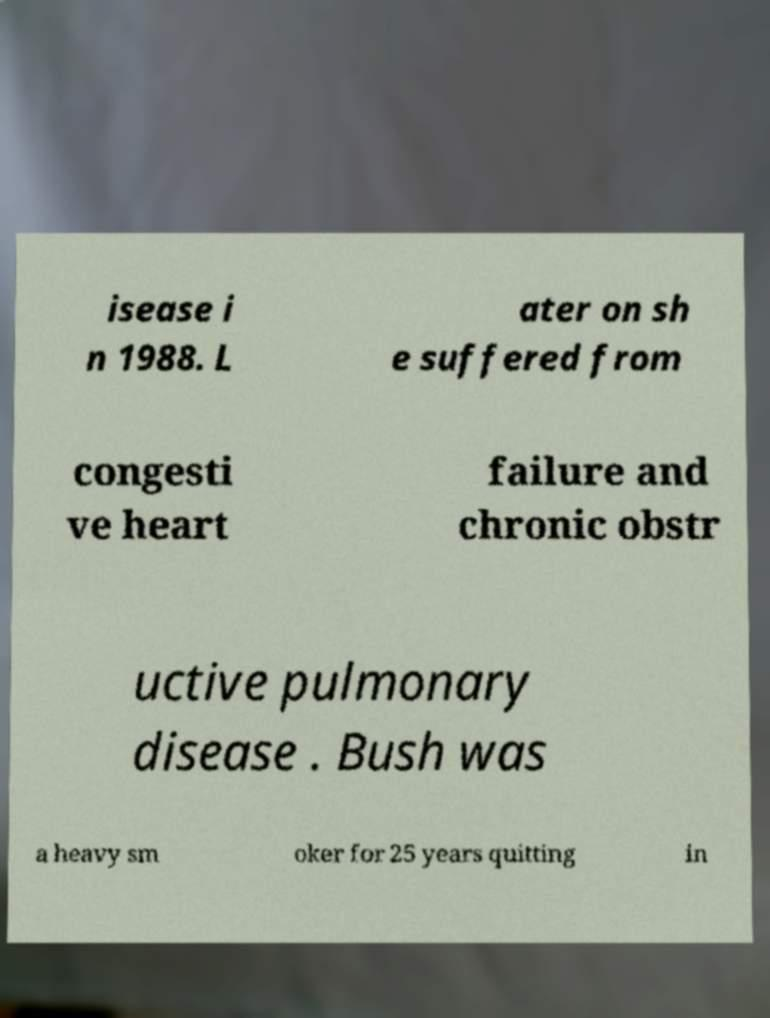There's text embedded in this image that I need extracted. Can you transcribe it verbatim? isease i n 1988. L ater on sh e suffered from congesti ve heart failure and chronic obstr uctive pulmonary disease . Bush was a heavy sm oker for 25 years quitting in 